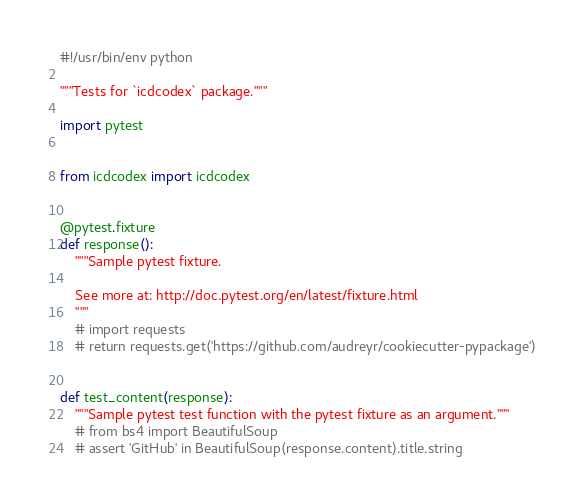<code> <loc_0><loc_0><loc_500><loc_500><_Python_>#!/usr/bin/env python

"""Tests for `icdcodex` package."""

import pytest


from icdcodex import icdcodex


@pytest.fixture
def response():
    """Sample pytest fixture.

    See more at: http://doc.pytest.org/en/latest/fixture.html
    """
    # import requests
    # return requests.get('https://github.com/audreyr/cookiecutter-pypackage')


def test_content(response):
    """Sample pytest test function with the pytest fixture as an argument."""
    # from bs4 import BeautifulSoup
    # assert 'GitHub' in BeautifulSoup(response.content).title.string
</code> 